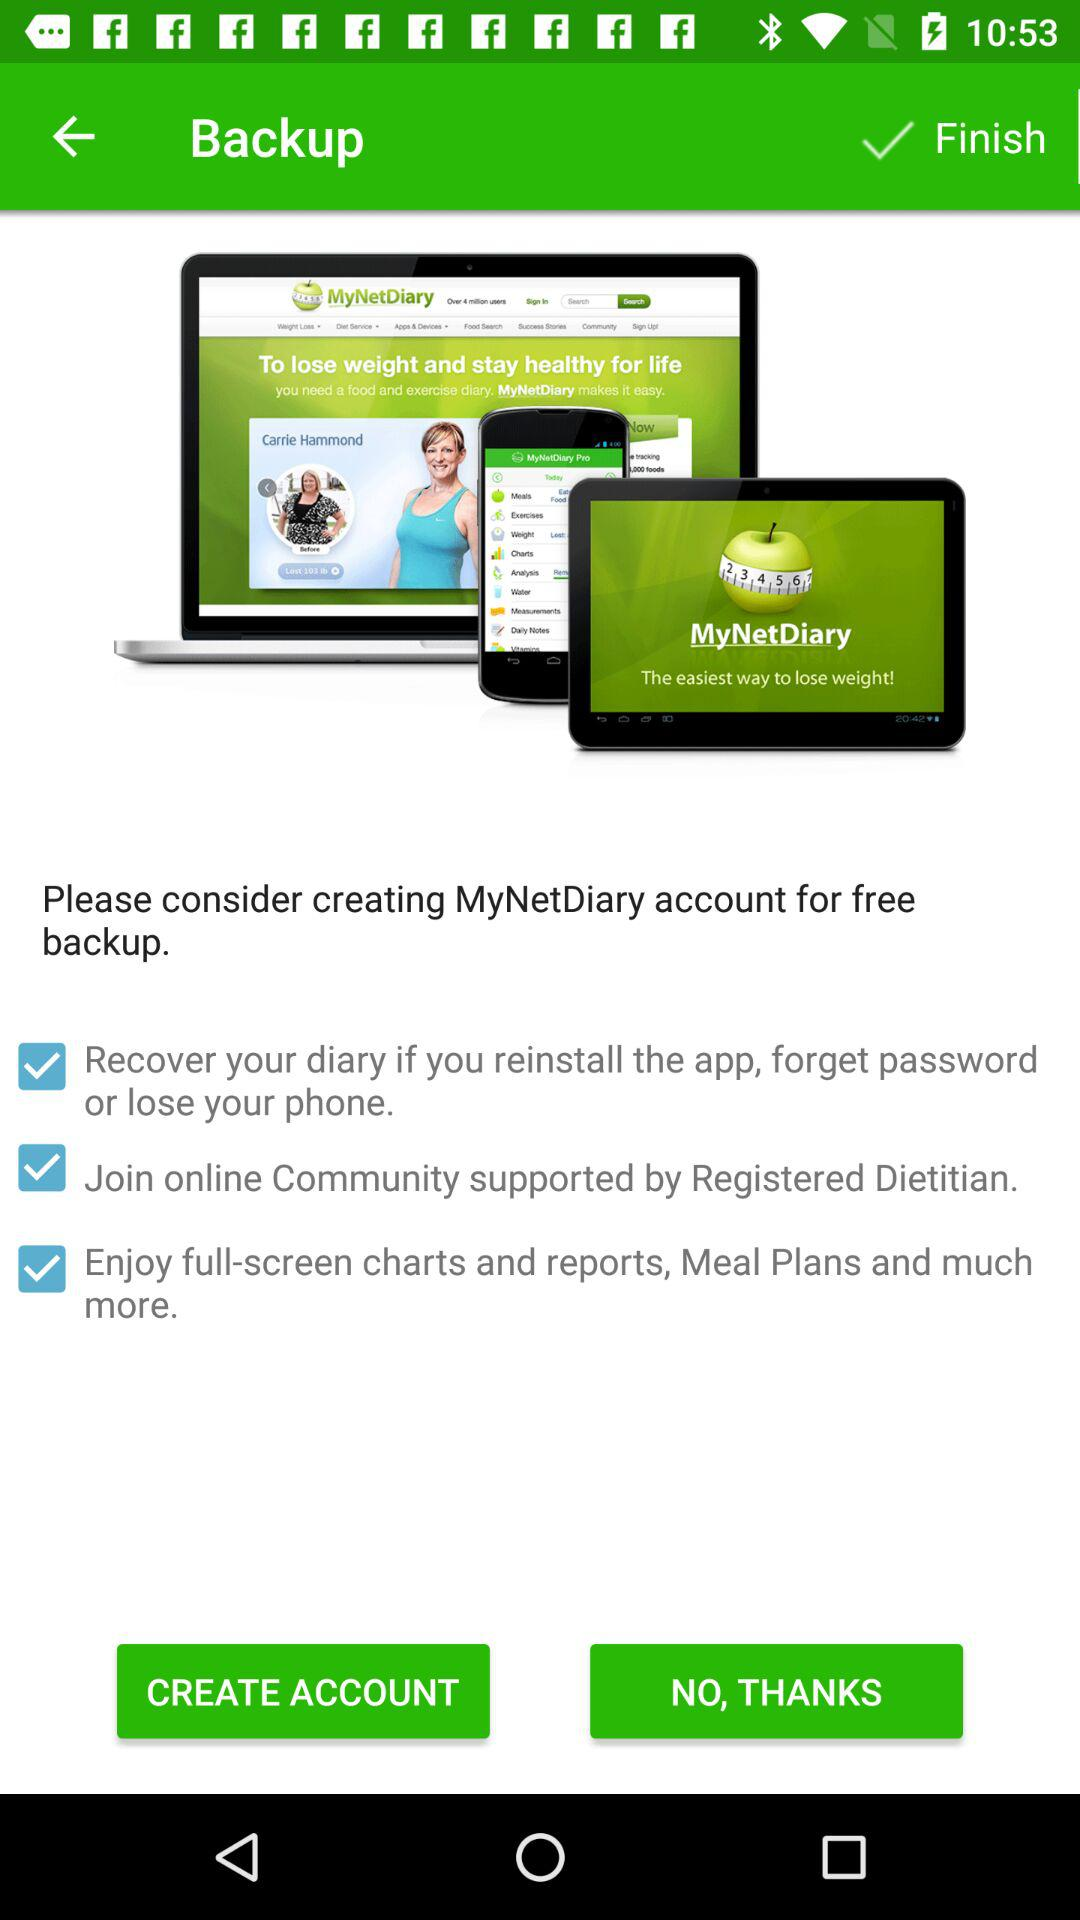What is the status of "Join online Community supported by Registered Dietitian"? The status of "Join online Community supported by Registered Dietitian" is "on". 